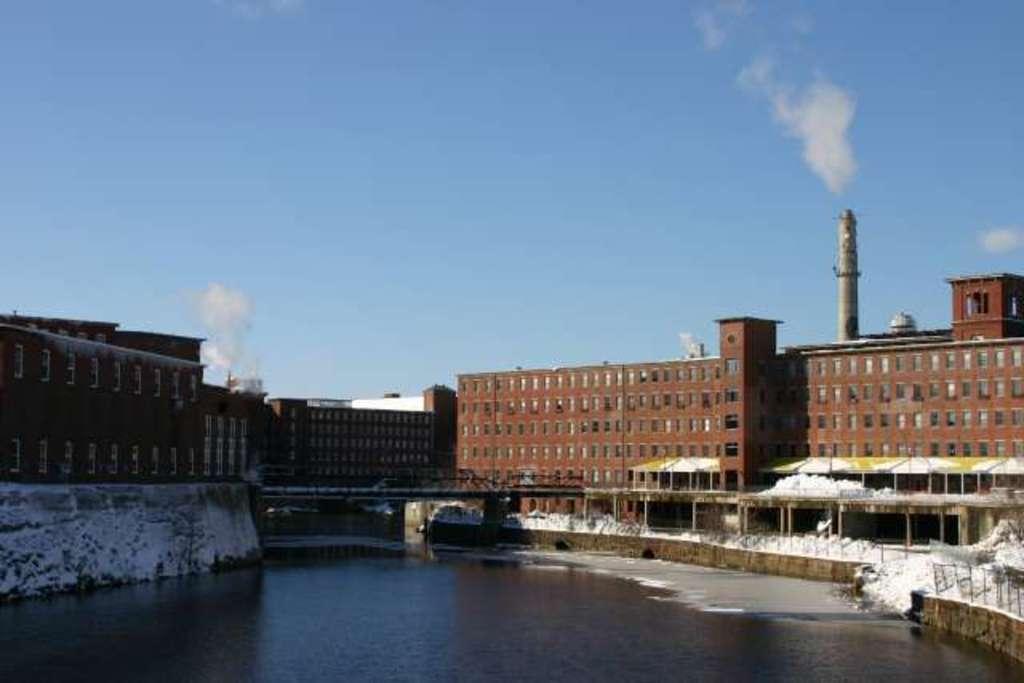In one or two sentences, can you explain what this image depicts? There is water and a bridge. There are buildings. 